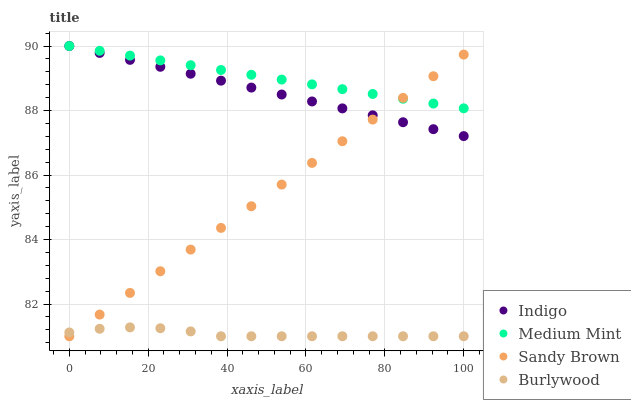Does Burlywood have the minimum area under the curve?
Answer yes or no. Yes. Does Medium Mint have the maximum area under the curve?
Answer yes or no. Yes. Does Sandy Brown have the minimum area under the curve?
Answer yes or no. No. Does Sandy Brown have the maximum area under the curve?
Answer yes or no. No. Is Medium Mint the smoothest?
Answer yes or no. Yes. Is Burlywood the roughest?
Answer yes or no. Yes. Is Sandy Brown the smoothest?
Answer yes or no. No. Is Sandy Brown the roughest?
Answer yes or no. No. Does Sandy Brown have the lowest value?
Answer yes or no. Yes. Does Indigo have the lowest value?
Answer yes or no. No. Does Indigo have the highest value?
Answer yes or no. Yes. Does Sandy Brown have the highest value?
Answer yes or no. No. Is Burlywood less than Indigo?
Answer yes or no. Yes. Is Indigo greater than Burlywood?
Answer yes or no. Yes. Does Medium Mint intersect Indigo?
Answer yes or no. Yes. Is Medium Mint less than Indigo?
Answer yes or no. No. Is Medium Mint greater than Indigo?
Answer yes or no. No. Does Burlywood intersect Indigo?
Answer yes or no. No. 